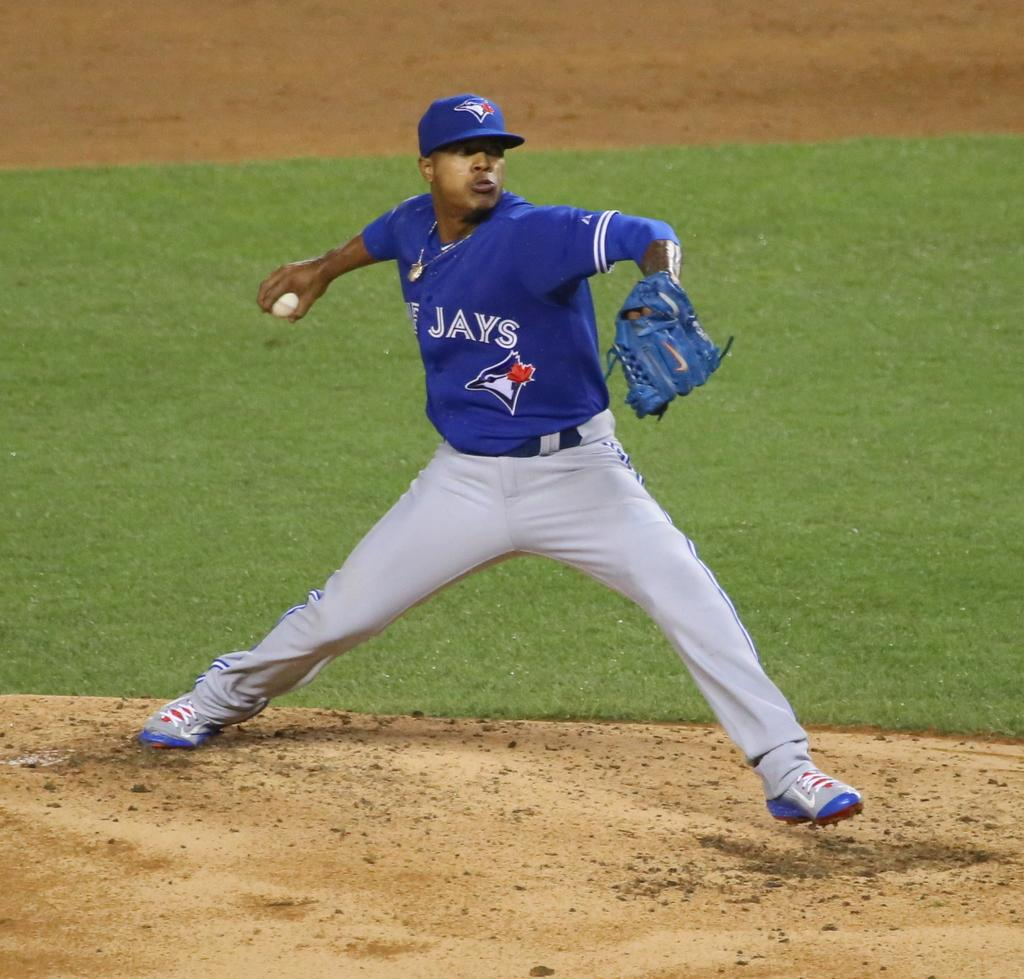What is the main subject of the image? There is a player in the image. What is the player doing in the image? The player is standing in a position to throw a ball. What type of surface is behind the player? There is a grass surface behind the player. What type of canvas is visible in the image? There is no canvas present in the image. Can you see a turkey in the image? There is no turkey present in the image. 